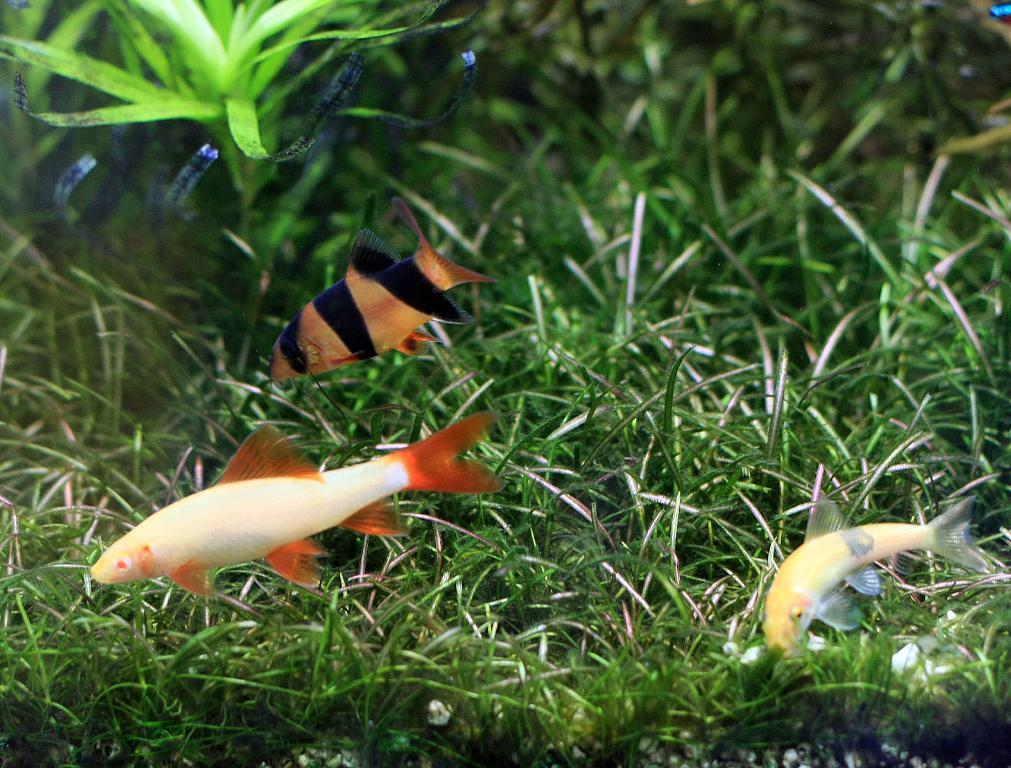What type of animals can be seen in the image? There are fishes in the image. What type of vegetation is present in the image? There is grass in the image. What type of quilt is being used to cover the fishes in the image? There is no quilt present in the image; it features fishes and grass. What type of spoon can be seen in the image? There is no spoon present in the image. 